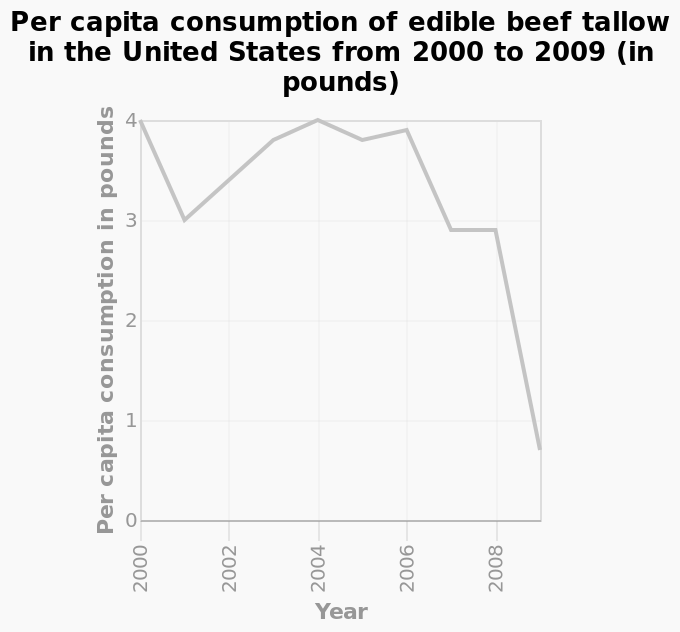<image>
please summary the statistics and relations of the chart During the period of 200-2009, Consumption of beef tallow was at its lowest in 2009 and it’s joint highest in 2000 and 2004. There was a significant dip in consumption from 4 to 3 pounds per capita in 2001. Consumption then rose steadily back to 4 pounds per capita by 2004. Since 2007 consumption has sharply decreased from 3.9 pounds per capita to 0.7 in 2009. How much did the consumption of beef tallow sharply decrease to in 2009? The consumption of beef tallow sharply decreased from 3.9 pounds per capita to 0.7 pounds per capita in 2009. 